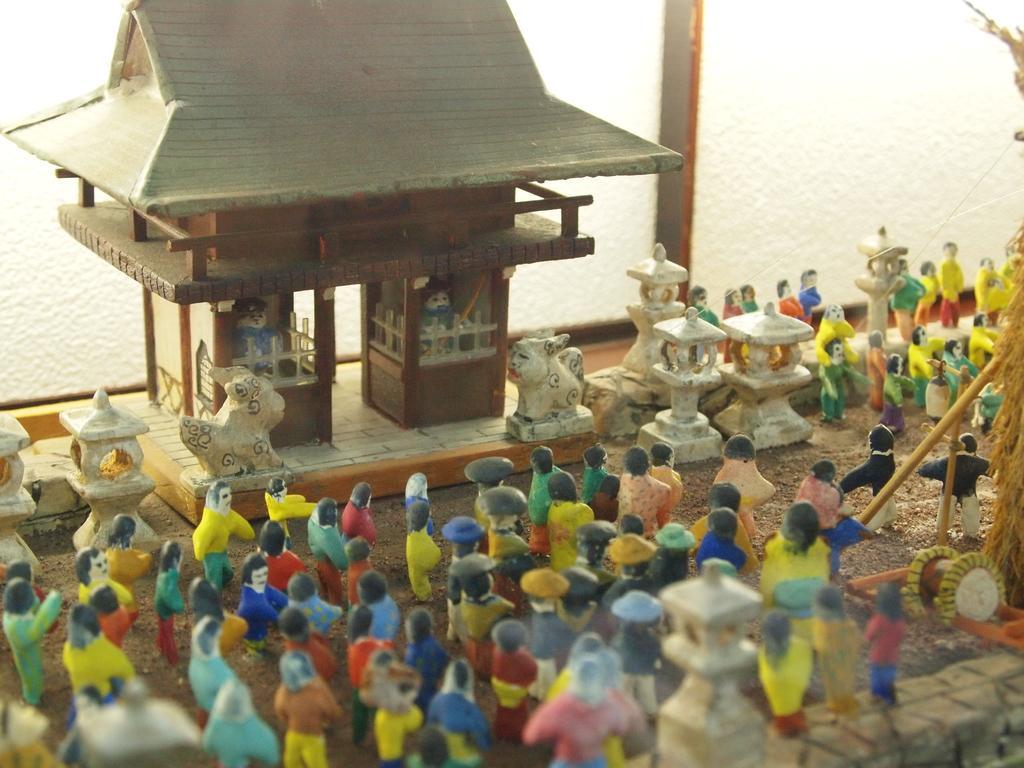In one or two sentences, can you explain what this image depicts? In this image we can see group of dolls standing on the ground. In the background we see a toy house in which two toys are placed. 